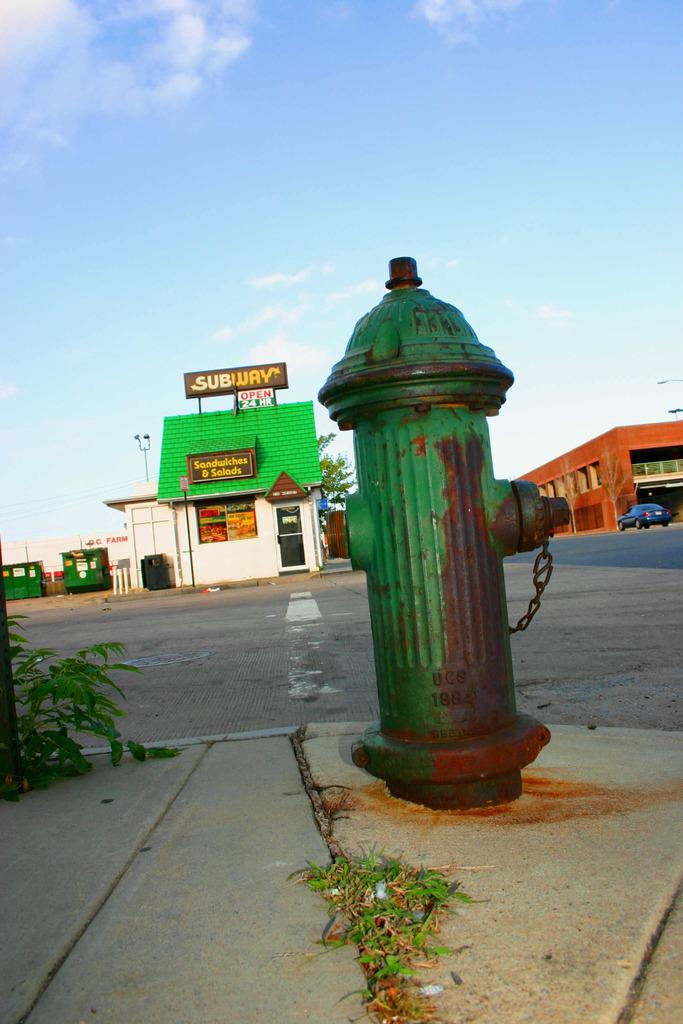<image>
Write a terse but informative summary of the picture. A green fire hydrant is outside of an old Subway restaurant. 